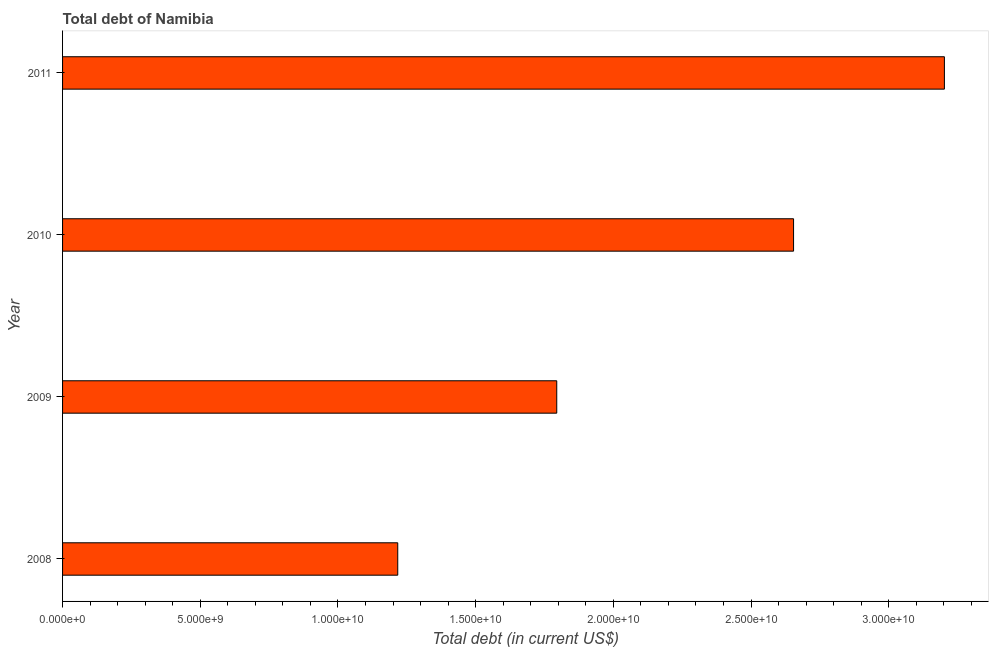Does the graph contain any zero values?
Give a very brief answer. No. What is the title of the graph?
Your answer should be compact. Total debt of Namibia. What is the label or title of the X-axis?
Offer a very short reply. Total debt (in current US$). What is the label or title of the Y-axis?
Make the answer very short. Year. What is the total debt in 2008?
Your response must be concise. 1.22e+1. Across all years, what is the maximum total debt?
Make the answer very short. 3.20e+1. Across all years, what is the minimum total debt?
Ensure brevity in your answer.  1.22e+1. In which year was the total debt minimum?
Your response must be concise. 2008. What is the sum of the total debt?
Your answer should be very brief. 8.87e+1. What is the difference between the total debt in 2009 and 2011?
Keep it short and to the point. -1.41e+1. What is the average total debt per year?
Offer a terse response. 2.22e+1. What is the median total debt?
Ensure brevity in your answer.  2.22e+1. In how many years, is the total debt greater than 28000000000 US$?
Give a very brief answer. 1. Do a majority of the years between 2009 and 2010 (inclusive) have total debt greater than 8000000000 US$?
Offer a terse response. Yes. What is the ratio of the total debt in 2009 to that in 2010?
Make the answer very short. 0.68. Is the total debt in 2008 less than that in 2011?
Provide a short and direct response. Yes. Is the difference between the total debt in 2010 and 2011 greater than the difference between any two years?
Provide a short and direct response. No. What is the difference between the highest and the second highest total debt?
Ensure brevity in your answer.  5.48e+09. What is the difference between the highest and the lowest total debt?
Provide a succinct answer. 1.98e+1. In how many years, is the total debt greater than the average total debt taken over all years?
Ensure brevity in your answer.  2. Are the values on the major ticks of X-axis written in scientific E-notation?
Provide a short and direct response. Yes. What is the Total debt (in current US$) in 2008?
Provide a succinct answer. 1.22e+1. What is the Total debt (in current US$) in 2009?
Ensure brevity in your answer.  1.79e+1. What is the Total debt (in current US$) in 2010?
Ensure brevity in your answer.  2.65e+1. What is the Total debt (in current US$) of 2011?
Offer a very short reply. 3.20e+1. What is the difference between the Total debt (in current US$) in 2008 and 2009?
Your response must be concise. -5.77e+09. What is the difference between the Total debt (in current US$) in 2008 and 2010?
Give a very brief answer. -1.44e+1. What is the difference between the Total debt (in current US$) in 2008 and 2011?
Ensure brevity in your answer.  -1.98e+1. What is the difference between the Total debt (in current US$) in 2009 and 2010?
Provide a short and direct response. -8.60e+09. What is the difference between the Total debt (in current US$) in 2009 and 2011?
Give a very brief answer. -1.41e+1. What is the difference between the Total debt (in current US$) in 2010 and 2011?
Keep it short and to the point. -5.48e+09. What is the ratio of the Total debt (in current US$) in 2008 to that in 2009?
Keep it short and to the point. 0.68. What is the ratio of the Total debt (in current US$) in 2008 to that in 2010?
Keep it short and to the point. 0.46. What is the ratio of the Total debt (in current US$) in 2008 to that in 2011?
Offer a terse response. 0.38. What is the ratio of the Total debt (in current US$) in 2009 to that in 2010?
Your response must be concise. 0.68. What is the ratio of the Total debt (in current US$) in 2009 to that in 2011?
Your answer should be very brief. 0.56. What is the ratio of the Total debt (in current US$) in 2010 to that in 2011?
Your answer should be compact. 0.83. 